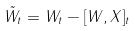Convert formula to latex. <formula><loc_0><loc_0><loc_500><loc_500>\tilde { W } _ { t } = W _ { t } - [ W , X ] _ { t }</formula> 